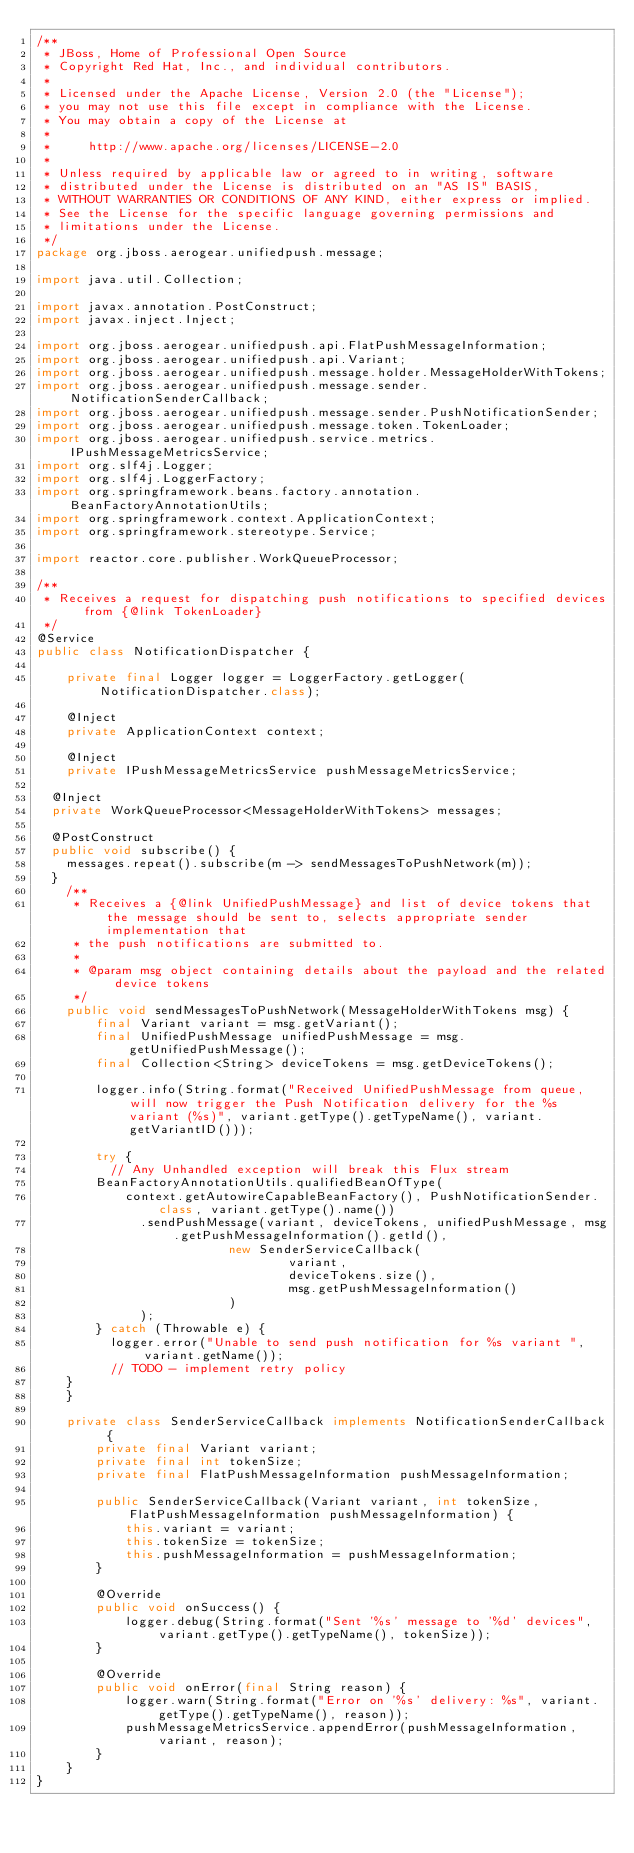<code> <loc_0><loc_0><loc_500><loc_500><_Java_>/**
 * JBoss, Home of Professional Open Source
 * Copyright Red Hat, Inc., and individual contributors.
 *
 * Licensed under the Apache License, Version 2.0 (the "License");
 * you may not use this file except in compliance with the License.
 * You may obtain a copy of the License at
 *
 *     http://www.apache.org/licenses/LICENSE-2.0
 *
 * Unless required by applicable law or agreed to in writing, software
 * distributed under the License is distributed on an "AS IS" BASIS,
 * WITHOUT WARRANTIES OR CONDITIONS OF ANY KIND, either express or implied.
 * See the License for the specific language governing permissions and
 * limitations under the License.
 */
package org.jboss.aerogear.unifiedpush.message;

import java.util.Collection;

import javax.annotation.PostConstruct;
import javax.inject.Inject;

import org.jboss.aerogear.unifiedpush.api.FlatPushMessageInformation;
import org.jboss.aerogear.unifiedpush.api.Variant;
import org.jboss.aerogear.unifiedpush.message.holder.MessageHolderWithTokens;
import org.jboss.aerogear.unifiedpush.message.sender.NotificationSenderCallback;
import org.jboss.aerogear.unifiedpush.message.sender.PushNotificationSender;
import org.jboss.aerogear.unifiedpush.message.token.TokenLoader;
import org.jboss.aerogear.unifiedpush.service.metrics.IPushMessageMetricsService;
import org.slf4j.Logger;
import org.slf4j.LoggerFactory;
import org.springframework.beans.factory.annotation.BeanFactoryAnnotationUtils;
import org.springframework.context.ApplicationContext;
import org.springframework.stereotype.Service;

import reactor.core.publisher.WorkQueueProcessor;

/**
 * Receives a request for dispatching push notifications to specified devices from {@link TokenLoader}
 */
@Service
public class NotificationDispatcher {

    private final Logger logger = LoggerFactory.getLogger(NotificationDispatcher.class);

    @Inject
    private ApplicationContext context;

    @Inject
    private IPushMessageMetricsService pushMessageMetricsService;

	@Inject
	private WorkQueueProcessor<MessageHolderWithTokens> messages;

	@PostConstruct
	public void subscribe() {
		messages.repeat().subscribe(m -> sendMessagesToPushNetwork(m));
	}
    /**
     * Receives a {@link UnifiedPushMessage} and list of device tokens that the message should be sent to, selects appropriate sender implementation that
     * the push notifications are submitted to.
     *
     * @param msg object containing details about the payload and the related device tokens
     */
    public void sendMessagesToPushNetwork(MessageHolderWithTokens msg) {
        final Variant variant = msg.getVariant();
        final UnifiedPushMessage unifiedPushMessage = msg.getUnifiedPushMessage();
        final Collection<String> deviceTokens = msg.getDeviceTokens();

        logger.info(String.format("Received UnifiedPushMessage from queue, will now trigger the Push Notification delivery for the %s variant (%s)", variant.getType().getTypeName(), variant.getVariantID()));

        try {
        	// Any Unhandled exception will break this Flux stream
    		BeanFactoryAnnotationUtils.qualifiedBeanOfType(
    				context.getAutowireCapableBeanFactory(), PushNotificationSender.class, variant.getType().name())
			    		.sendPushMessage(variant, deviceTokens, unifiedPushMessage, msg.getPushMessageInformation().getId(),
			                    new SenderServiceCallback(
			                            variant,
			                            deviceTokens.size(),
			                            msg.getPushMessageInformation()
			                    )
			    		);
        } catch (Throwable e) {
        	logger.error("Unable to send push notification for %s variant ", variant.getName());
        	// TODO - implement retry policy
		}
    }

    private class SenderServiceCallback implements NotificationSenderCallback {
        private final Variant variant;
        private final int tokenSize;
        private final FlatPushMessageInformation pushMessageInformation;

        public SenderServiceCallback(Variant variant, int tokenSize, FlatPushMessageInformation pushMessageInformation) {
            this.variant = variant;
            this.tokenSize = tokenSize;
            this.pushMessageInformation = pushMessageInformation;
        }

        @Override
        public void onSuccess() {
            logger.debug(String.format("Sent '%s' message to '%d' devices", variant.getType().getTypeName(), tokenSize));
        }

        @Override
        public void onError(final String reason) {
            logger.warn(String.format("Error on '%s' delivery: %s", variant.getType().getTypeName(), reason));
            pushMessageMetricsService.appendError(pushMessageInformation, variant, reason);
        }
    }
}
</code> 